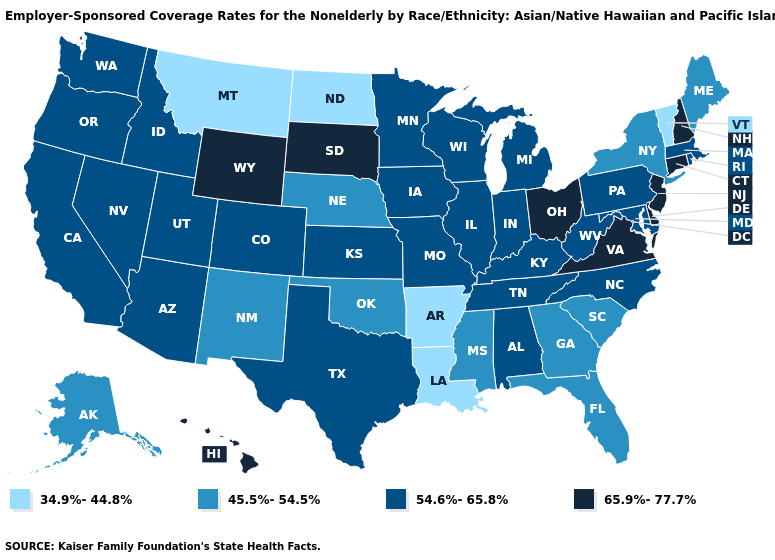What is the value of Mississippi?
Give a very brief answer. 45.5%-54.5%. Is the legend a continuous bar?
Write a very short answer. No. Among the states that border Rhode Island , does Connecticut have the lowest value?
Quick response, please. No. Does Delaware have the highest value in the South?
Short answer required. Yes. Name the states that have a value in the range 54.6%-65.8%?
Write a very short answer. Alabama, Arizona, California, Colorado, Idaho, Illinois, Indiana, Iowa, Kansas, Kentucky, Maryland, Massachusetts, Michigan, Minnesota, Missouri, Nevada, North Carolina, Oregon, Pennsylvania, Rhode Island, Tennessee, Texas, Utah, Washington, West Virginia, Wisconsin. What is the value of Utah?
Concise answer only. 54.6%-65.8%. Does Utah have the highest value in the USA?
Write a very short answer. No. What is the highest value in the USA?
Keep it brief. 65.9%-77.7%. What is the lowest value in the USA?
Be succinct. 34.9%-44.8%. Among the states that border Delaware , which have the highest value?
Give a very brief answer. New Jersey. Does Montana have the lowest value in the West?
Keep it brief. Yes. What is the value of Alaska?
Concise answer only. 45.5%-54.5%. Among the states that border Missouri , which have the lowest value?
Write a very short answer. Arkansas. Does Texas have the same value as Iowa?
Write a very short answer. Yes. 